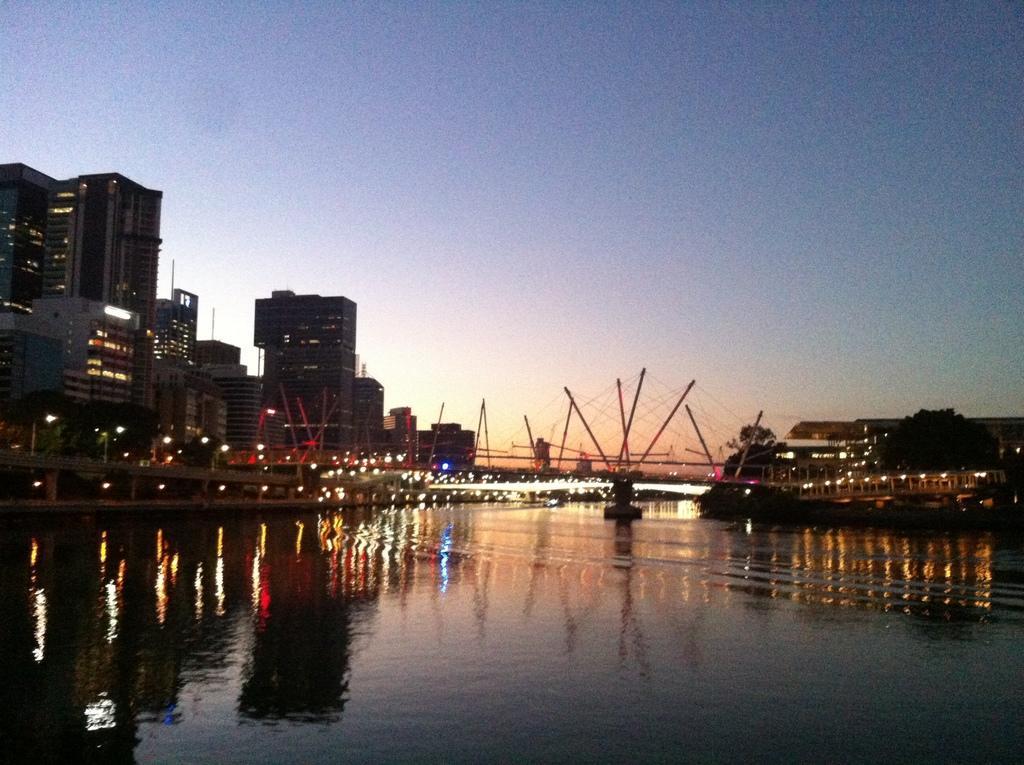Describe this image in one or two sentences. In this picture we can see water,buildings and we can see sky in the background. 